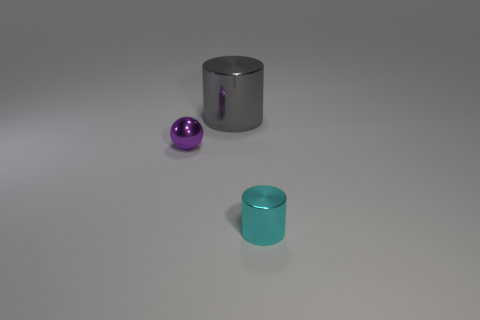Is there any other thing that is the same size as the gray cylinder?
Ensure brevity in your answer.  No. What is the size of the cyan shiny object that is the same shape as the big gray shiny object?
Give a very brief answer. Small. Are there fewer gray metal cylinders than small gray shiny things?
Provide a short and direct response. No. Is there another big gray object that has the same material as the large object?
Offer a very short reply. No. Is the shape of the tiny cyan thing the same as the metallic thing to the left of the large gray metallic thing?
Your response must be concise. No. There is a gray shiny object; are there any purple things to the left of it?
Give a very brief answer. Yes. How many purple things have the same shape as the large gray shiny object?
Provide a succinct answer. 0. Does the purple object have the same material as the thing in front of the tiny purple thing?
Provide a succinct answer. Yes. What number of big blue rubber spheres are there?
Your answer should be very brief. 0. What is the size of the object behind the purple object?
Your answer should be very brief. Large. 